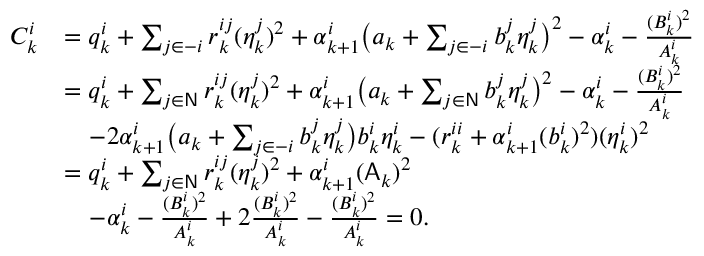Convert formula to latex. <formula><loc_0><loc_0><loc_500><loc_500>\begin{array} { r l } { C _ { k } ^ { i } } & { = q _ { k } ^ { i } + \sum _ { j \in - i } r _ { k } ^ { i j } ( \eta _ { k } ^ { j } ) ^ { 2 } + \alpha _ { k + 1 } ^ { i } \left ( a _ { k } + \sum _ { j \in - i } b _ { k } ^ { j } \eta _ { k } ^ { j } \right ) ^ { 2 } - \alpha _ { k } ^ { i } - \frac { ( B _ { k } ^ { i } ) ^ { 2 } } { A _ { k } ^ { i } } } \\ & { = q _ { k } ^ { i } + \sum _ { j \in N } r _ { k } ^ { i j } ( \eta _ { k } ^ { j } ) ^ { 2 } + \alpha _ { k + 1 } ^ { i } \left ( a _ { k } + \sum _ { j \in N } b _ { k } ^ { j } \eta _ { k } ^ { j } \right ) ^ { 2 } - \alpha _ { k } ^ { i } - \frac { ( B _ { k } ^ { i } ) ^ { 2 } } { A _ { k } ^ { i } } } \\ & { \quad - 2 \alpha _ { k + 1 } ^ { i } \left ( a _ { k } + \sum _ { j \in - i } b _ { k } ^ { j } \eta _ { k } ^ { j } \right ) b _ { k } ^ { i } \eta _ { k } ^ { i } - ( r _ { k } ^ { i i } + \alpha _ { k + 1 } ^ { i } ( b _ { k } ^ { i } ) ^ { 2 } ) ( \eta _ { k } ^ { i } ) ^ { 2 } } \\ & { = q _ { k } ^ { i } + \sum _ { j \in N } r _ { k } ^ { i j } ( \eta _ { k } ^ { j } ) ^ { 2 } + \alpha _ { k + 1 } ^ { i } ( A _ { k } ) ^ { 2 } } \\ & { \quad - \alpha _ { k } ^ { i } - \frac { ( B _ { k } ^ { i } ) ^ { 2 } } { A _ { k } ^ { i } } + 2 \frac { ( B _ { k } ^ { i } ) ^ { 2 } } { A _ { k } ^ { i } } - \frac { ( B _ { k } ^ { i } ) ^ { 2 } } { A _ { k } ^ { i } } = 0 . } \end{array}</formula> 